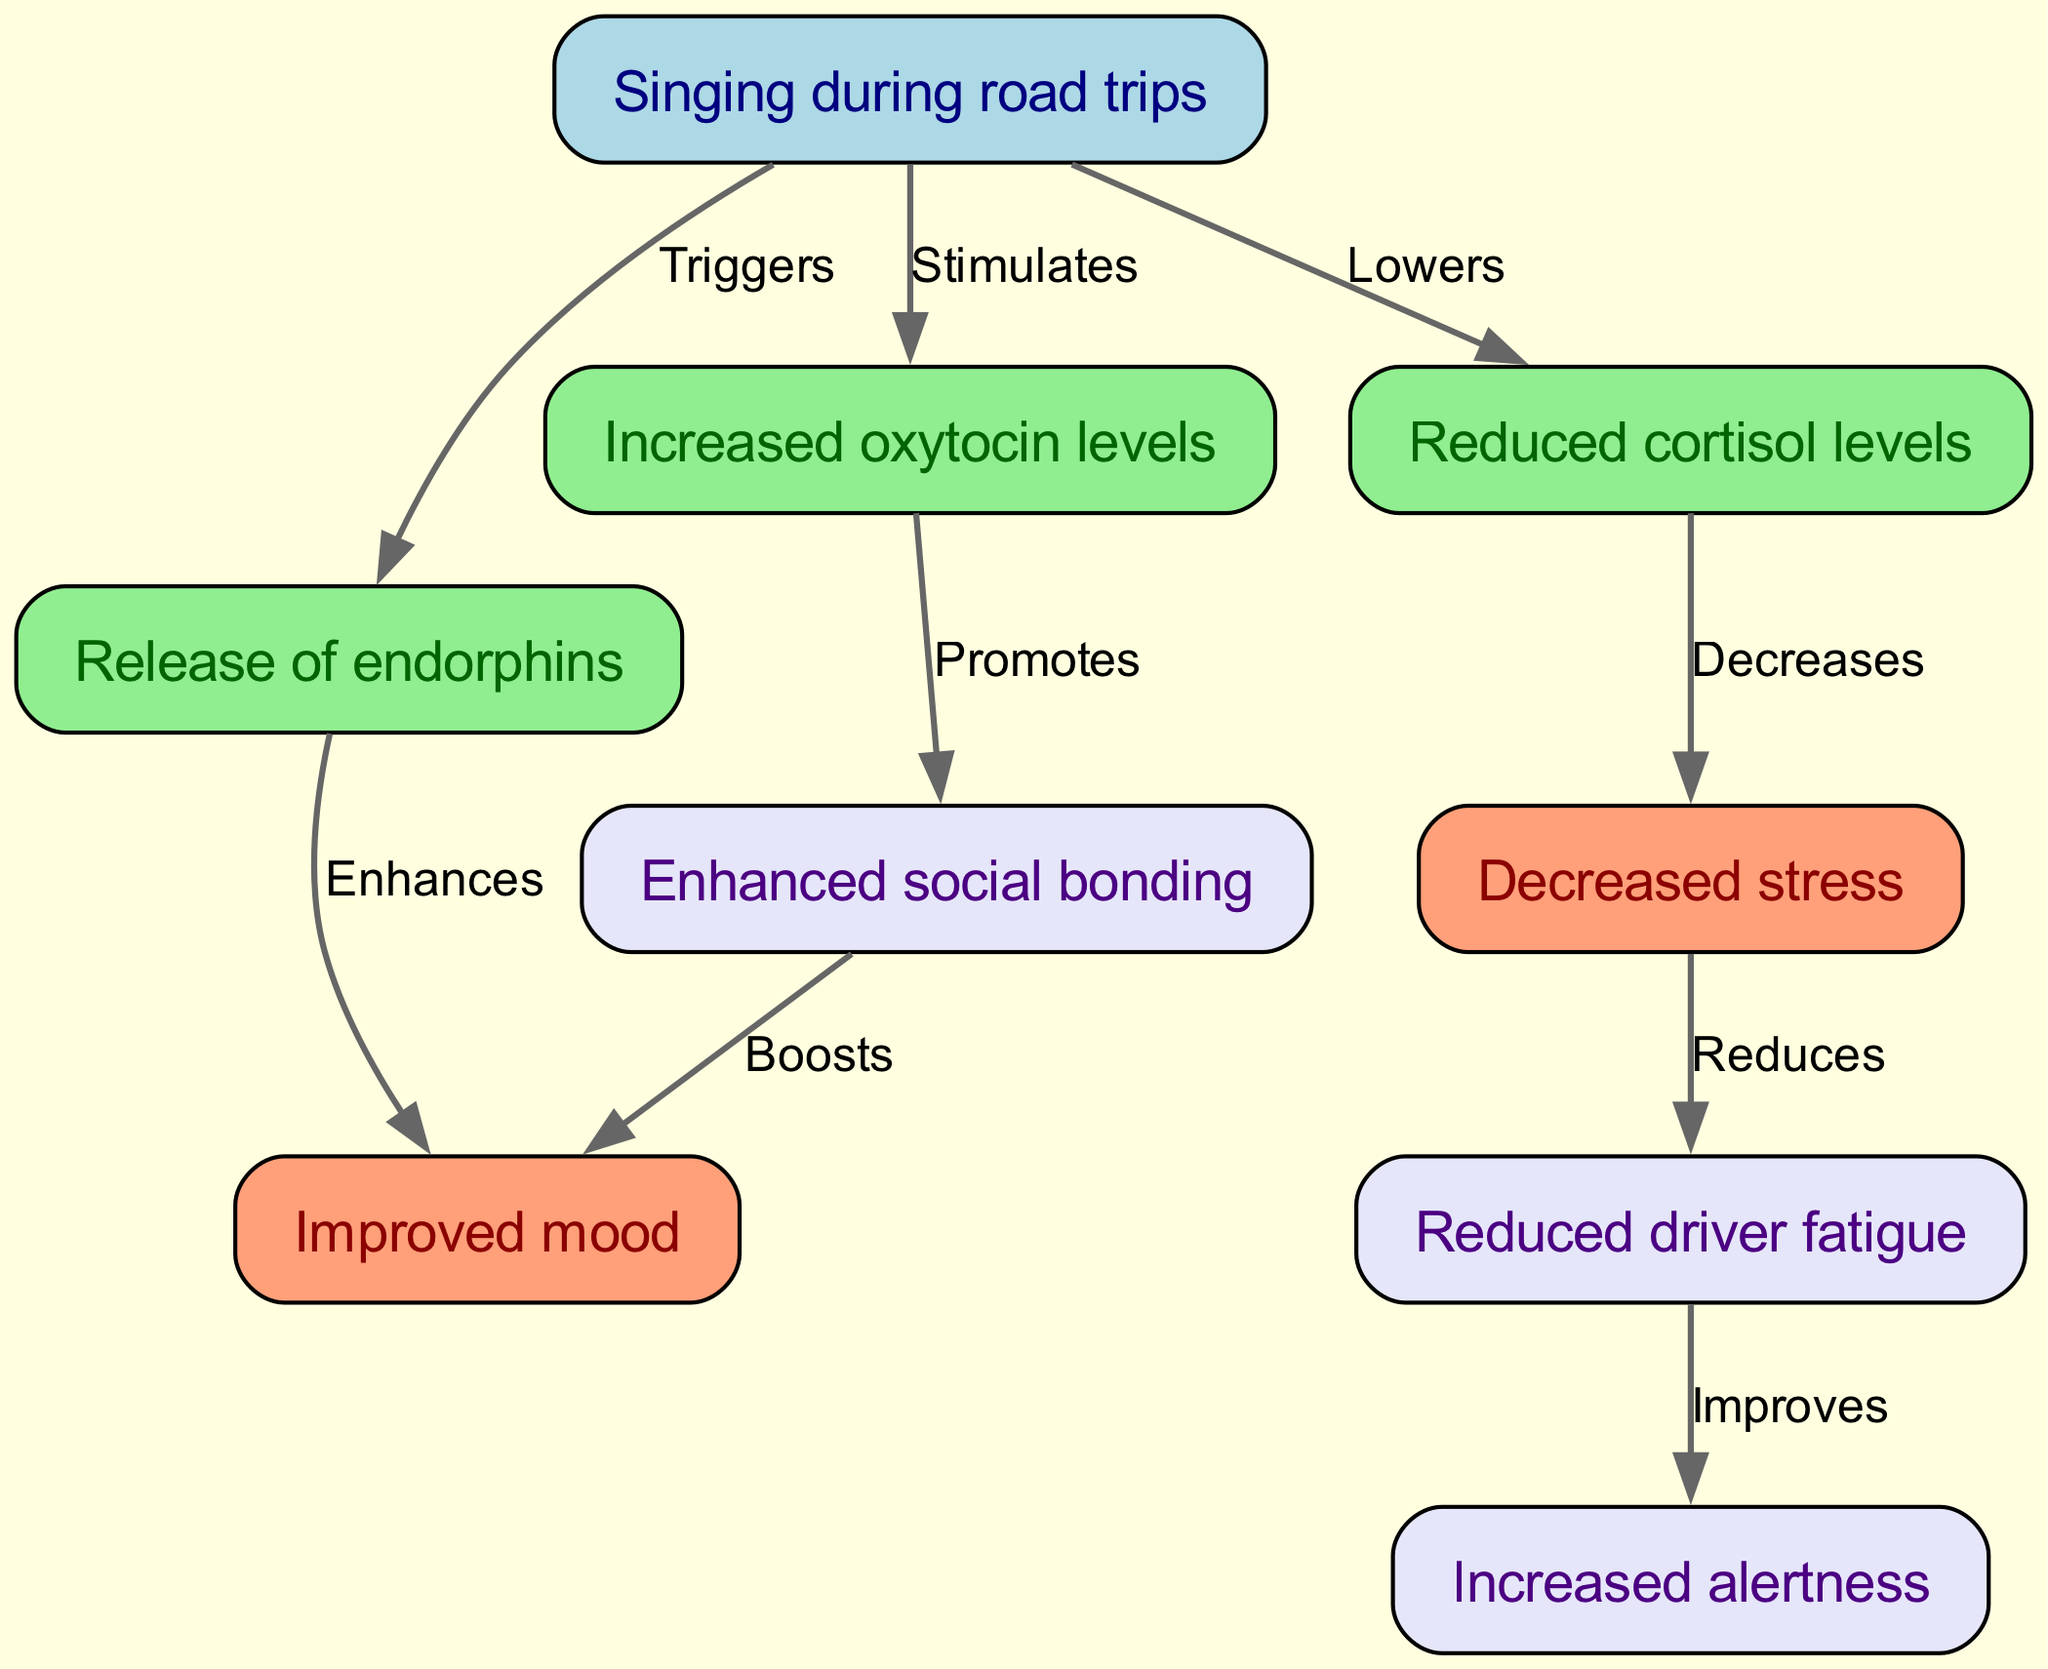What is one physiological effect of singing during road trips? The diagram indicates that singing triggers the release of endorphins.
Answer: Endorphins What is the relationship between cortisol and stress? The diagram shows that cortisol levels decrease stress levels. This flow indicates an inverse relationship; as cortisol decreases, stress decreases.
Answer: Decreases How many edges are present in the diagram? Upon counting the connections, the diagram includes a total of eight edges.
Answer: Eight What does increased oxytocin levels promote? The diagram specifically indicates that increased oxytocin levels promote bonding among individuals.
Answer: Bonding If cortisol is lowered, what effect does it have on stress? According to the diagram's flow, lowering cortisol is directly linked to a decrease in stress, showing a cause-and-effect relationship.
Answer: Decreases Which two nodes directly connect to improved mood? The diagram presents the nodes for endorphins and social bonding as the two nodes connected to improved mood.
Answer: Endorphins and bonding What overall effect does singing have on driver fatigue through its impact on stress? The diagram indicates that decreased stress reduces fatigue, suggesting that the act of singing indirectly improves alertness by reducing fatigue.
Answer: Improves alertness Which node represents a protective action against fatigue? The diagram clearly identifies that the node 'fatigue' leads to a node that states 'increased alertness' which is an overall protective action against fatigue.
Answer: Increased alertness 